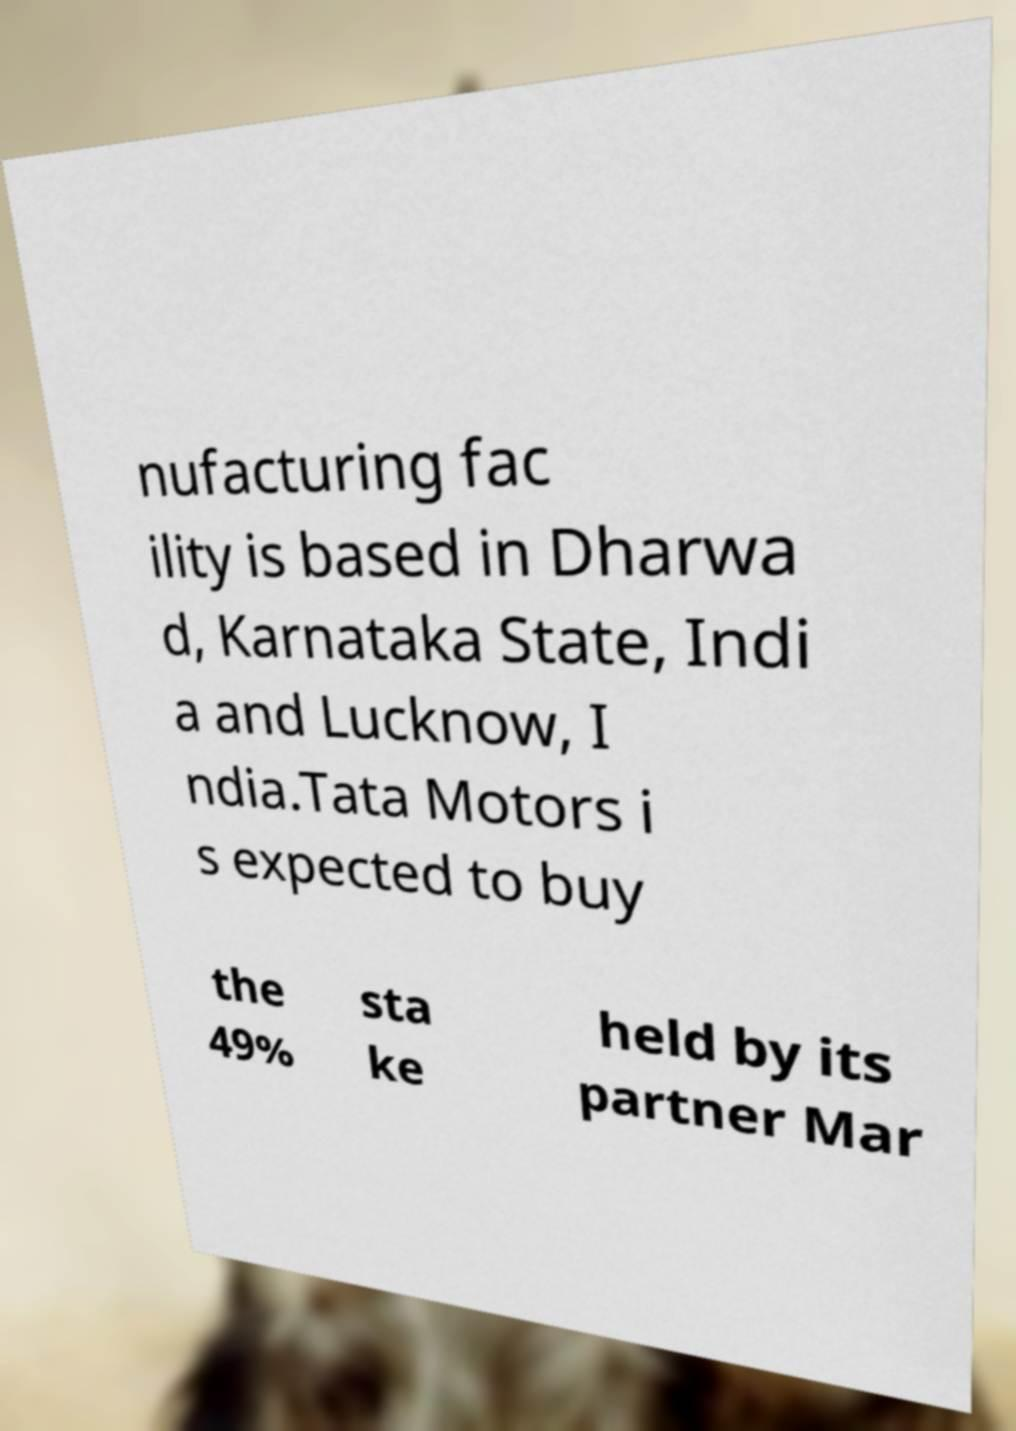Could you assist in decoding the text presented in this image and type it out clearly? nufacturing fac ility is based in Dharwa d, Karnataka State, Indi a and Lucknow, I ndia.Tata Motors i s expected to buy the 49% sta ke held by its partner Mar 